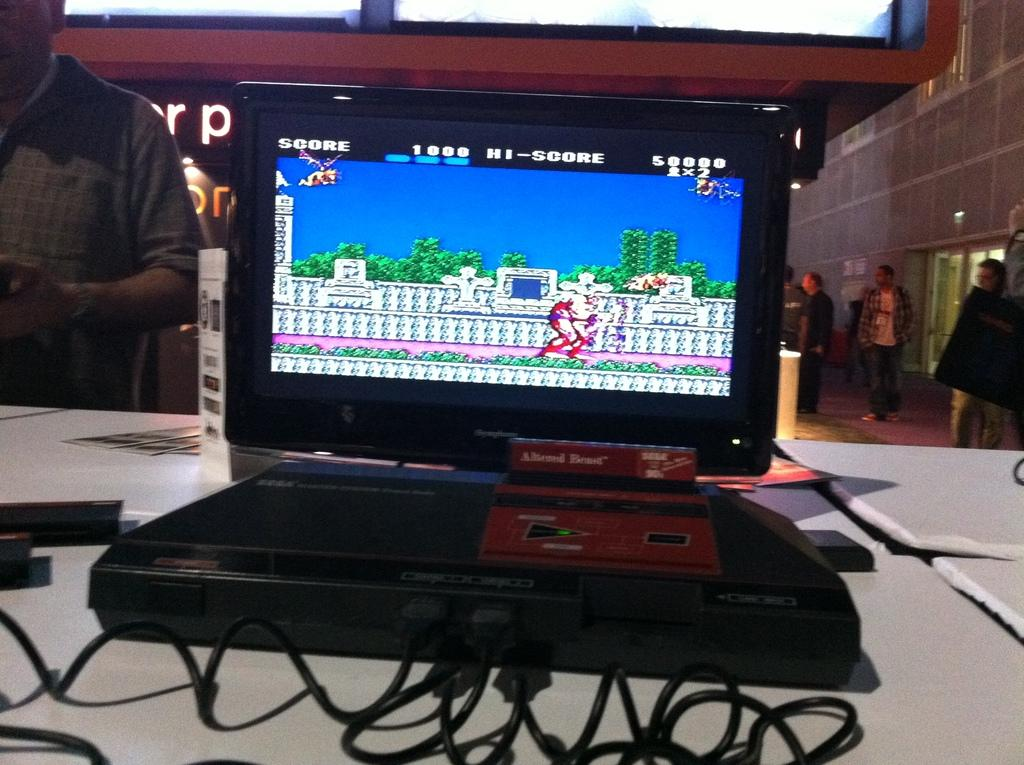<image>
Relay a brief, clear account of the picture shown. The game Altered Beast being played on a laptop, with a high score of 50,000. 